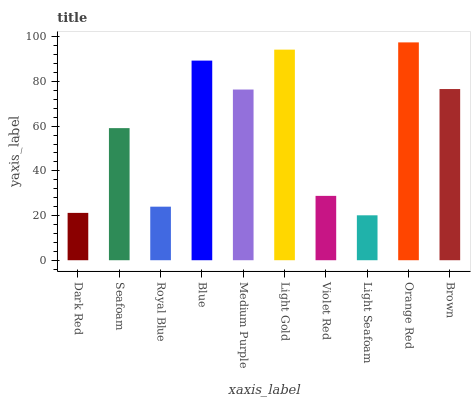Is Light Seafoam the minimum?
Answer yes or no. Yes. Is Orange Red the maximum?
Answer yes or no. Yes. Is Seafoam the minimum?
Answer yes or no. No. Is Seafoam the maximum?
Answer yes or no. No. Is Seafoam greater than Dark Red?
Answer yes or no. Yes. Is Dark Red less than Seafoam?
Answer yes or no. Yes. Is Dark Red greater than Seafoam?
Answer yes or no. No. Is Seafoam less than Dark Red?
Answer yes or no. No. Is Medium Purple the high median?
Answer yes or no. Yes. Is Seafoam the low median?
Answer yes or no. Yes. Is Light Gold the high median?
Answer yes or no. No. Is Royal Blue the low median?
Answer yes or no. No. 